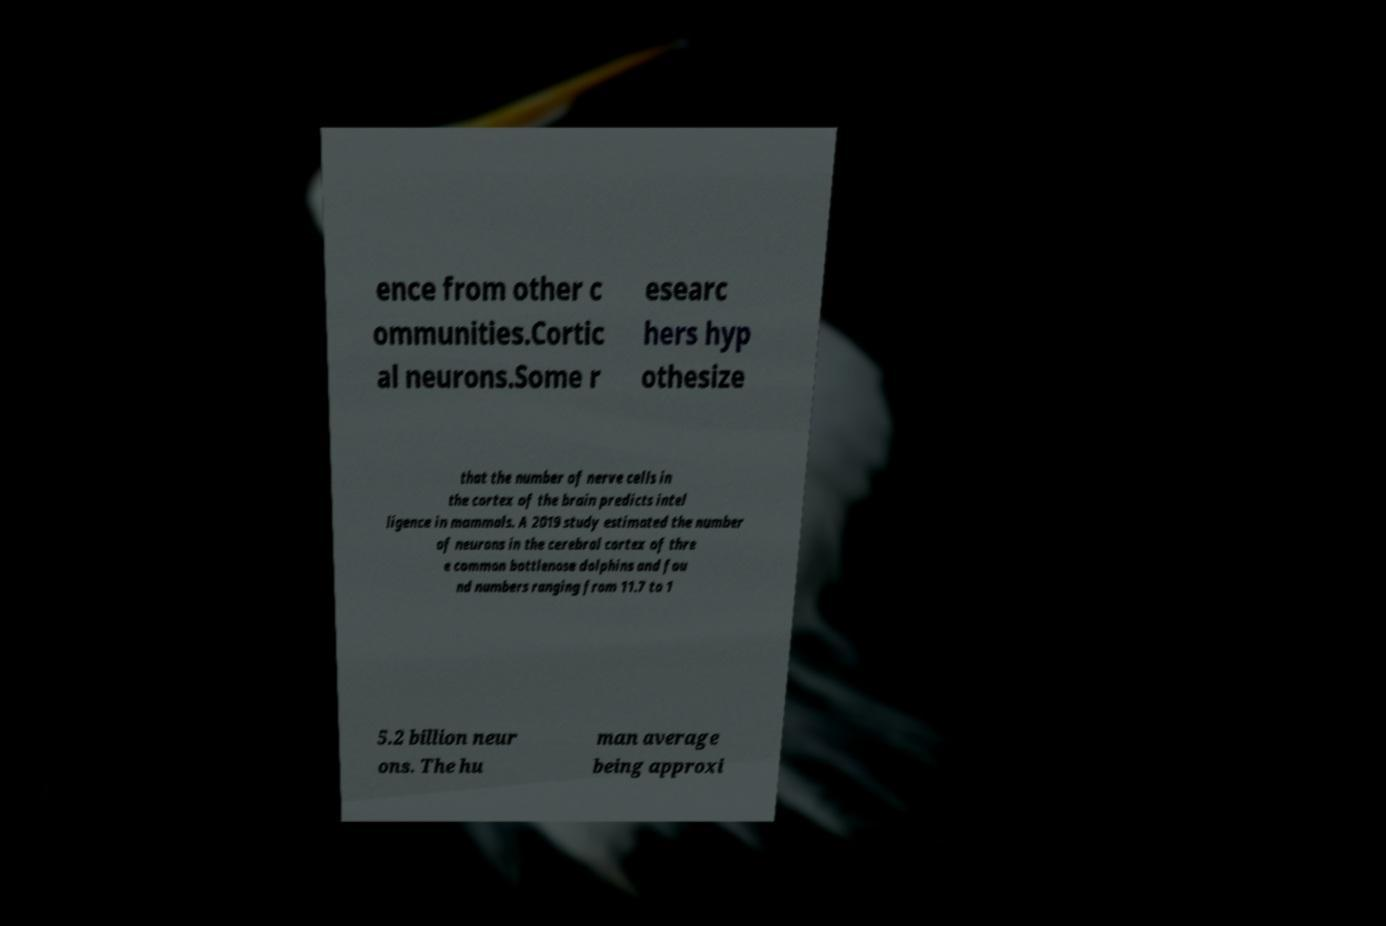I need the written content from this picture converted into text. Can you do that? ence from other c ommunities.Cortic al neurons.Some r esearc hers hyp othesize that the number of nerve cells in the cortex of the brain predicts intel ligence in mammals. A 2019 study estimated the number of neurons in the cerebral cortex of thre e common bottlenose dolphins and fou nd numbers ranging from 11.7 to 1 5.2 billion neur ons. The hu man average being approxi 